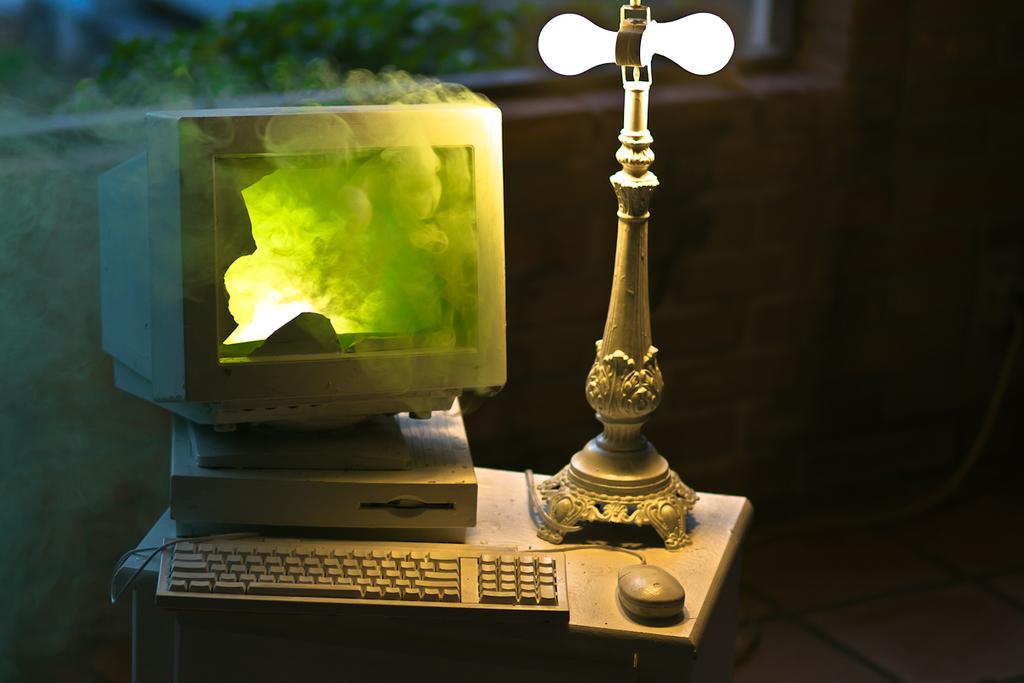In one or two sentences, can you explain what this image depicts? In this image there is a table, on that table there is a table lamp, keyboard, mouse and a broken monitor and there is smoke. 